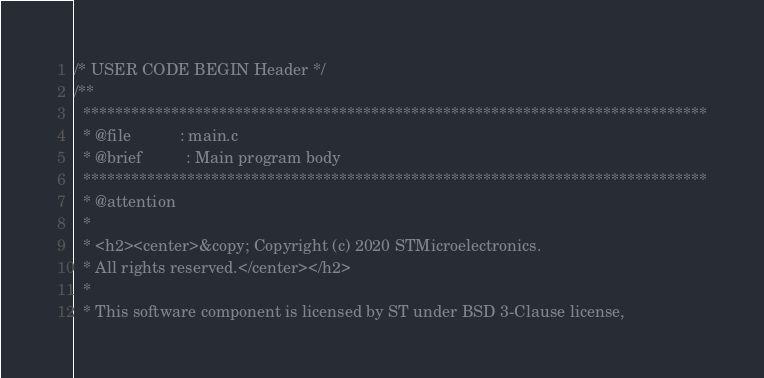<code> <loc_0><loc_0><loc_500><loc_500><_C_>/* USER CODE BEGIN Header */
/**
  ******************************************************************************
  * @file           : main.c
  * @brief          : Main program body
  ******************************************************************************
  * @attention
  *
  * <h2><center>&copy; Copyright (c) 2020 STMicroelectronics.
  * All rights reserved.</center></h2>
  *
  * This software component is licensed by ST under BSD 3-Clause license,</code> 